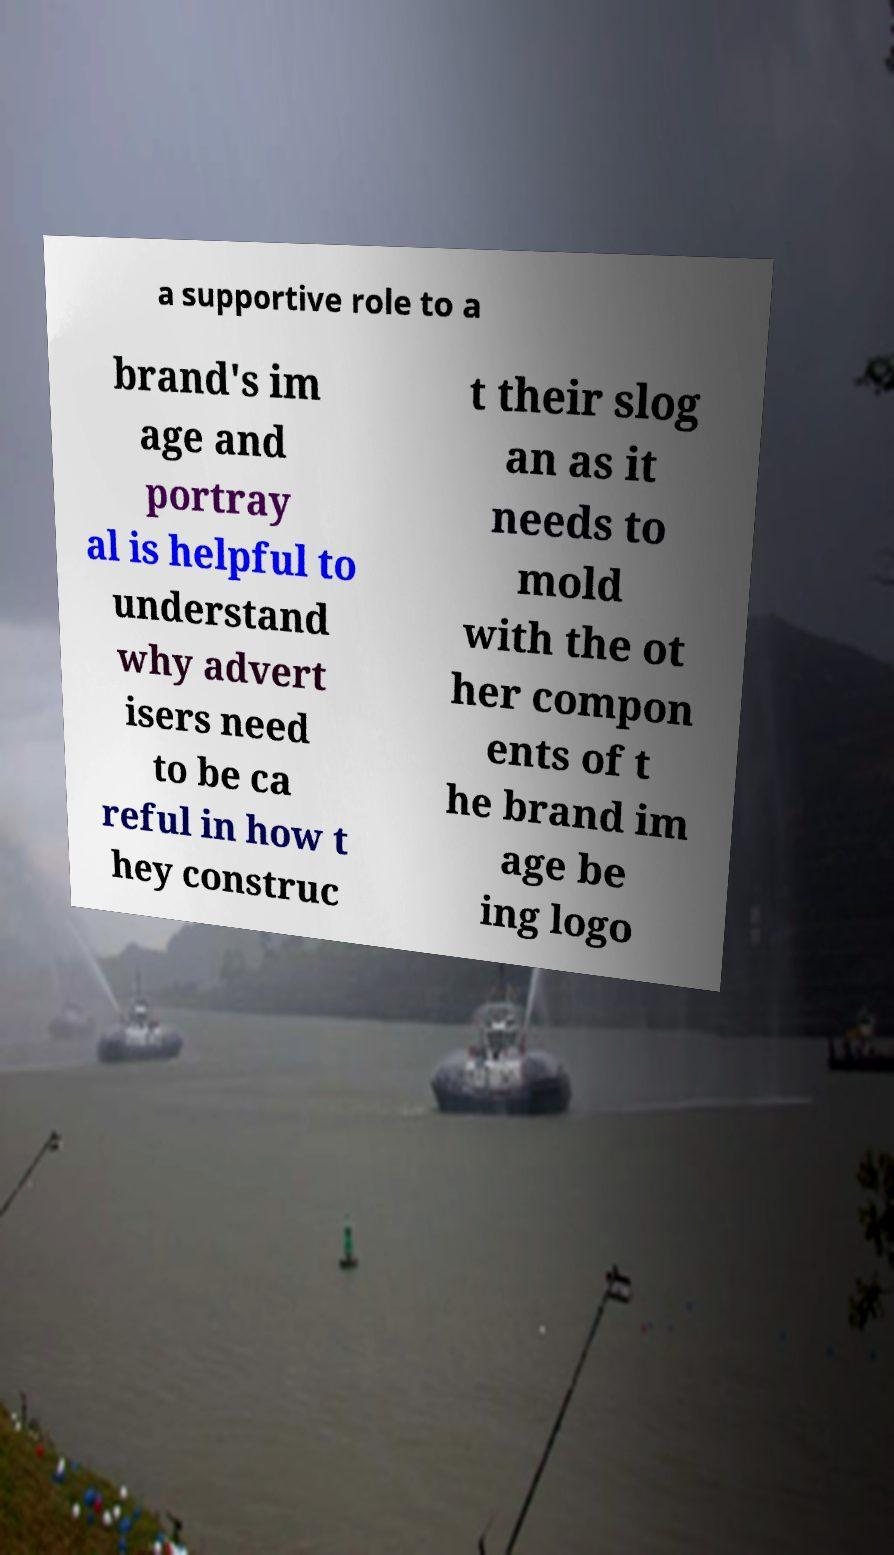What messages or text are displayed in this image? I need them in a readable, typed format. a supportive role to a brand's im age and portray al is helpful to understand why advert isers need to be ca reful in how t hey construc t their slog an as it needs to mold with the ot her compon ents of t he brand im age be ing logo 